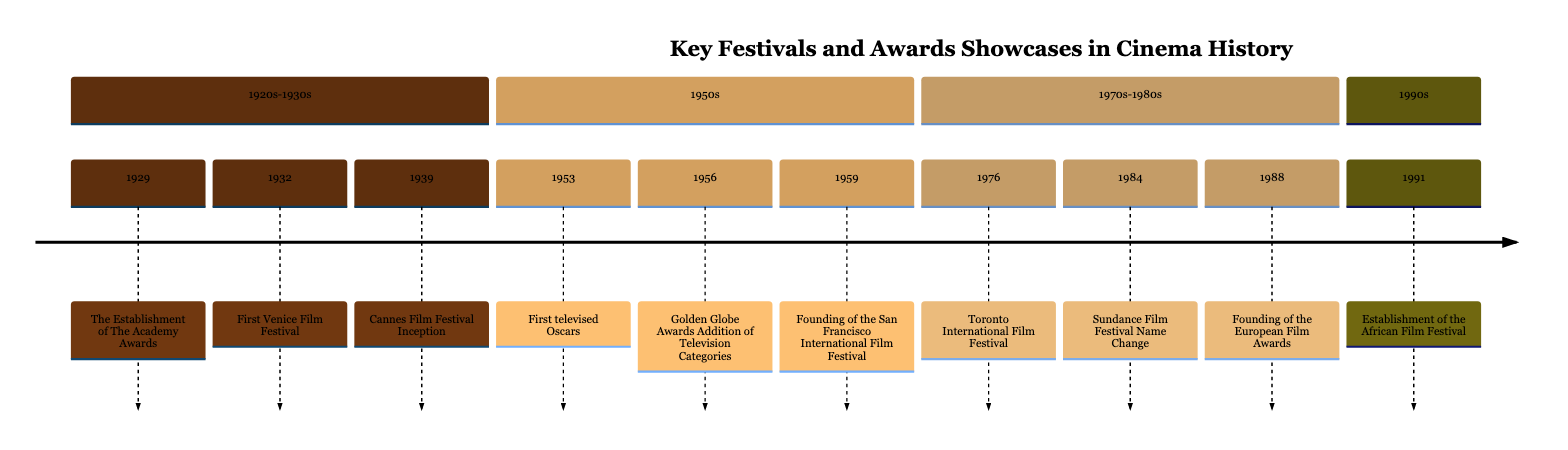What year did the Academy Awards first take place? The diagram indicates that the establishment of the Academy Awards happened in 1929. This is depicted at the beginning of the timeline, clearly labeled with the event and year associated.
Answer: 1929 What event occurred in 1956? By checking the timeline, in the section labeled "1950s," the event occurring in 1956 is indicated as the addition of television categories to the Golden Globe Awards. This is a clear milestone in the history of awards showcases in cinema.
Answer: Golden Globe Awards Addition of Television Categories How many awards shows and festivals are listed in the 1970s-1980s section? Counting the events in the "1970s-1980s" section reveals three distinct events: the Toronto International Film Festival in 1976, the Sundance Film Festival name change in 1984, and the founding of the European Film Awards in 1988. Hence, the total count of events in this section is three.
Answer: 3 What is the significance of the year 1953 in this timeline? The year 1953 is significant because it marks the first time the Oscars were televised. This event introduced a broader audience to the ceremony, which is reflected in the corresponding entry in the timeline.
Answer: First televised Oscars Which event celebrated African cinema and when was it established? The timeline shows that the establishment of the African Film Festival occurred in 1991, with a clear focus on celebrating African cinema and storytelling traditions. This indicates an important cultural milestone reflected in the timeline.
Answer: Establishment of the African Film Festival Which two festivals were founded in 1932 and 1959? From the timeline, in 1932, the first Venice Film Festival was founded, while in 1959, the San Francisco International Film Festival was established. These entries can be easily found in their respective sections of the timeline.
Answer: First Venice Film Festival, Founding of the San Francisco International Film Festival What is the timeline's section that includes the Sundance Film Festival? The Sundance Film Festival is located in the "1970s-1980s" section of the timeline, which highlights major events in that decade. This section groups important milestones from that era effectively.
Answer: 1970s-1980s What notable change occurred to the Sundance Film Festival in 1984? According to the timeline, the notable change in 1984 was the rebranding of the Utah/US Film Festival to the Sundance Film Festival. This marks an important shift in its identity and reputation.
Answer: Sundance Film Festival Name Change Which film festival is the oldest in the United States? The San Francisco International Film Festival, founded in 1959, is noted in the timeline as the oldest film festival in the U.S., providing historical context to its significance within American cinema.
Answer: Founding of the San Francisco International Film Festival 